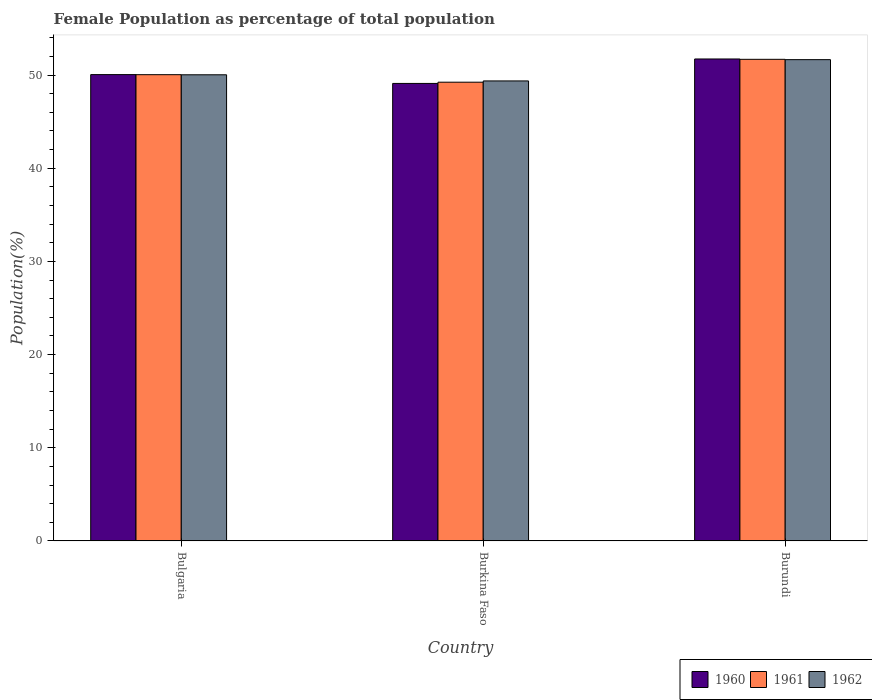How many different coloured bars are there?
Provide a short and direct response. 3. How many groups of bars are there?
Offer a very short reply. 3. Are the number of bars per tick equal to the number of legend labels?
Ensure brevity in your answer.  Yes. Are the number of bars on each tick of the X-axis equal?
Keep it short and to the point. Yes. What is the label of the 2nd group of bars from the left?
Ensure brevity in your answer.  Burkina Faso. In how many cases, is the number of bars for a given country not equal to the number of legend labels?
Provide a succinct answer. 0. What is the female population in in 1962 in Bulgaria?
Keep it short and to the point. 50.03. Across all countries, what is the maximum female population in in 1961?
Your response must be concise. 51.69. Across all countries, what is the minimum female population in in 1961?
Your response must be concise. 49.24. In which country was the female population in in 1961 maximum?
Offer a terse response. Burundi. In which country was the female population in in 1962 minimum?
Keep it short and to the point. Burkina Faso. What is the total female population in in 1960 in the graph?
Your answer should be compact. 150.88. What is the difference between the female population in in 1960 in Burkina Faso and that in Burundi?
Offer a terse response. -2.63. What is the difference between the female population in in 1960 in Burkina Faso and the female population in in 1961 in Bulgaria?
Keep it short and to the point. -0.94. What is the average female population in in 1960 per country?
Ensure brevity in your answer.  50.29. What is the difference between the female population in of/in 1962 and female population in of/in 1960 in Bulgaria?
Ensure brevity in your answer.  -0.02. What is the ratio of the female population in in 1962 in Bulgaria to that in Burkina Faso?
Your answer should be very brief. 1.01. Is the female population in in 1961 in Bulgaria less than that in Burkina Faso?
Give a very brief answer. No. What is the difference between the highest and the second highest female population in in 1962?
Provide a short and direct response. -0.66. What is the difference between the highest and the lowest female population in in 1960?
Ensure brevity in your answer.  2.63. In how many countries, is the female population in in 1960 greater than the average female population in in 1960 taken over all countries?
Provide a succinct answer. 1. What does the 3rd bar from the right in Burkina Faso represents?
Keep it short and to the point. 1960. Are all the bars in the graph horizontal?
Your answer should be compact. No. How many countries are there in the graph?
Your response must be concise. 3. Does the graph contain any zero values?
Your response must be concise. No. Does the graph contain grids?
Offer a very short reply. No. What is the title of the graph?
Make the answer very short. Female Population as percentage of total population. Does "1976" appear as one of the legend labels in the graph?
Give a very brief answer. No. What is the label or title of the X-axis?
Your answer should be very brief. Country. What is the label or title of the Y-axis?
Provide a short and direct response. Population(%). What is the Population(%) in 1960 in Bulgaria?
Provide a short and direct response. 50.05. What is the Population(%) of 1961 in Bulgaria?
Give a very brief answer. 50.04. What is the Population(%) of 1962 in Bulgaria?
Keep it short and to the point. 50.03. What is the Population(%) in 1960 in Burkina Faso?
Give a very brief answer. 49.1. What is the Population(%) of 1961 in Burkina Faso?
Give a very brief answer. 49.24. What is the Population(%) of 1962 in Burkina Faso?
Offer a terse response. 49.37. What is the Population(%) of 1960 in Burundi?
Offer a terse response. 51.73. What is the Population(%) of 1961 in Burundi?
Offer a very short reply. 51.69. What is the Population(%) in 1962 in Burundi?
Offer a very short reply. 51.65. Across all countries, what is the maximum Population(%) of 1960?
Make the answer very short. 51.73. Across all countries, what is the maximum Population(%) of 1961?
Make the answer very short. 51.69. Across all countries, what is the maximum Population(%) of 1962?
Give a very brief answer. 51.65. Across all countries, what is the minimum Population(%) in 1960?
Provide a short and direct response. 49.1. Across all countries, what is the minimum Population(%) of 1961?
Provide a succinct answer. 49.24. Across all countries, what is the minimum Population(%) of 1962?
Your answer should be very brief. 49.37. What is the total Population(%) of 1960 in the graph?
Keep it short and to the point. 150.88. What is the total Population(%) of 1961 in the graph?
Make the answer very short. 150.97. What is the total Population(%) of 1962 in the graph?
Give a very brief answer. 151.06. What is the difference between the Population(%) in 1960 in Bulgaria and that in Burkina Faso?
Make the answer very short. 0.95. What is the difference between the Population(%) of 1961 in Bulgaria and that in Burkina Faso?
Your response must be concise. 0.81. What is the difference between the Population(%) of 1962 in Bulgaria and that in Burkina Faso?
Keep it short and to the point. 0.66. What is the difference between the Population(%) in 1960 in Bulgaria and that in Burundi?
Ensure brevity in your answer.  -1.68. What is the difference between the Population(%) in 1961 in Bulgaria and that in Burundi?
Ensure brevity in your answer.  -1.65. What is the difference between the Population(%) of 1962 in Bulgaria and that in Burundi?
Offer a very short reply. -1.62. What is the difference between the Population(%) of 1960 in Burkina Faso and that in Burundi?
Your response must be concise. -2.63. What is the difference between the Population(%) in 1961 in Burkina Faso and that in Burundi?
Offer a very short reply. -2.45. What is the difference between the Population(%) of 1962 in Burkina Faso and that in Burundi?
Provide a succinct answer. -2.28. What is the difference between the Population(%) in 1960 in Bulgaria and the Population(%) in 1961 in Burkina Faso?
Your response must be concise. 0.81. What is the difference between the Population(%) in 1960 in Bulgaria and the Population(%) in 1962 in Burkina Faso?
Offer a very short reply. 0.68. What is the difference between the Population(%) in 1961 in Bulgaria and the Population(%) in 1962 in Burkina Faso?
Your answer should be compact. 0.67. What is the difference between the Population(%) of 1960 in Bulgaria and the Population(%) of 1961 in Burundi?
Offer a terse response. -1.64. What is the difference between the Population(%) in 1960 in Bulgaria and the Population(%) in 1962 in Burundi?
Your answer should be compact. -1.6. What is the difference between the Population(%) of 1961 in Bulgaria and the Population(%) of 1962 in Burundi?
Ensure brevity in your answer.  -1.61. What is the difference between the Population(%) in 1960 in Burkina Faso and the Population(%) in 1961 in Burundi?
Offer a terse response. -2.59. What is the difference between the Population(%) of 1960 in Burkina Faso and the Population(%) of 1962 in Burundi?
Your answer should be very brief. -2.55. What is the difference between the Population(%) of 1961 in Burkina Faso and the Population(%) of 1962 in Burundi?
Provide a succinct answer. -2.42. What is the average Population(%) of 1960 per country?
Make the answer very short. 50.29. What is the average Population(%) in 1961 per country?
Ensure brevity in your answer.  50.32. What is the average Population(%) of 1962 per country?
Give a very brief answer. 50.35. What is the difference between the Population(%) in 1960 and Population(%) in 1961 in Bulgaria?
Provide a short and direct response. 0.01. What is the difference between the Population(%) in 1960 and Population(%) in 1962 in Bulgaria?
Offer a very short reply. 0.02. What is the difference between the Population(%) of 1961 and Population(%) of 1962 in Bulgaria?
Your answer should be very brief. 0.01. What is the difference between the Population(%) of 1960 and Population(%) of 1961 in Burkina Faso?
Your answer should be compact. -0.13. What is the difference between the Population(%) of 1960 and Population(%) of 1962 in Burkina Faso?
Your answer should be very brief. -0.27. What is the difference between the Population(%) in 1961 and Population(%) in 1962 in Burkina Faso?
Offer a terse response. -0.13. What is the difference between the Population(%) of 1960 and Population(%) of 1961 in Burundi?
Keep it short and to the point. 0.04. What is the difference between the Population(%) in 1960 and Population(%) in 1962 in Burundi?
Ensure brevity in your answer.  0.07. What is the difference between the Population(%) of 1961 and Population(%) of 1962 in Burundi?
Ensure brevity in your answer.  0.04. What is the ratio of the Population(%) of 1960 in Bulgaria to that in Burkina Faso?
Ensure brevity in your answer.  1.02. What is the ratio of the Population(%) in 1961 in Bulgaria to that in Burkina Faso?
Ensure brevity in your answer.  1.02. What is the ratio of the Population(%) in 1962 in Bulgaria to that in Burkina Faso?
Your response must be concise. 1.01. What is the ratio of the Population(%) in 1960 in Bulgaria to that in Burundi?
Keep it short and to the point. 0.97. What is the ratio of the Population(%) in 1961 in Bulgaria to that in Burundi?
Provide a succinct answer. 0.97. What is the ratio of the Population(%) of 1962 in Bulgaria to that in Burundi?
Give a very brief answer. 0.97. What is the ratio of the Population(%) in 1960 in Burkina Faso to that in Burundi?
Your response must be concise. 0.95. What is the ratio of the Population(%) in 1961 in Burkina Faso to that in Burundi?
Your answer should be compact. 0.95. What is the ratio of the Population(%) in 1962 in Burkina Faso to that in Burundi?
Offer a terse response. 0.96. What is the difference between the highest and the second highest Population(%) in 1960?
Provide a succinct answer. 1.68. What is the difference between the highest and the second highest Population(%) of 1961?
Provide a succinct answer. 1.65. What is the difference between the highest and the second highest Population(%) of 1962?
Keep it short and to the point. 1.62. What is the difference between the highest and the lowest Population(%) in 1960?
Provide a short and direct response. 2.63. What is the difference between the highest and the lowest Population(%) in 1961?
Give a very brief answer. 2.45. What is the difference between the highest and the lowest Population(%) in 1962?
Your response must be concise. 2.28. 